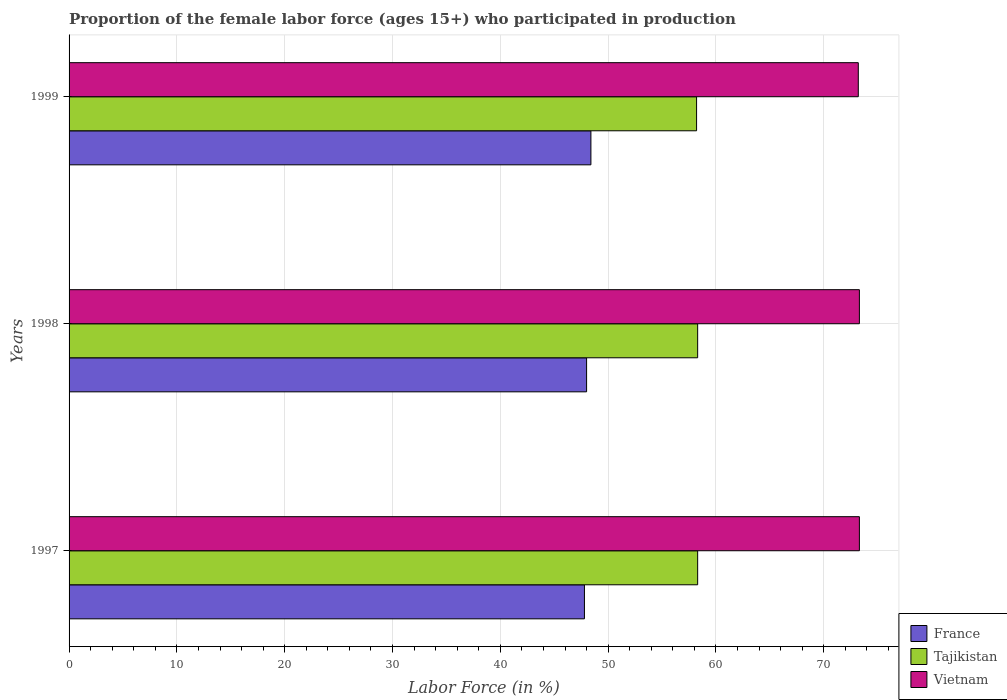How many groups of bars are there?
Give a very brief answer. 3. How many bars are there on the 2nd tick from the top?
Your response must be concise. 3. How many bars are there on the 3rd tick from the bottom?
Give a very brief answer. 3. What is the proportion of the female labor force who participated in production in Vietnam in 1998?
Your answer should be compact. 73.3. Across all years, what is the maximum proportion of the female labor force who participated in production in Vietnam?
Your answer should be very brief. 73.3. Across all years, what is the minimum proportion of the female labor force who participated in production in France?
Keep it short and to the point. 47.8. In which year was the proportion of the female labor force who participated in production in Vietnam minimum?
Ensure brevity in your answer.  1999. What is the total proportion of the female labor force who participated in production in Tajikistan in the graph?
Offer a terse response. 174.8. What is the difference between the proportion of the female labor force who participated in production in Vietnam in 1998 and that in 1999?
Provide a short and direct response. 0.1. What is the difference between the proportion of the female labor force who participated in production in France in 1997 and the proportion of the female labor force who participated in production in Vietnam in 1998?
Offer a very short reply. -25.5. What is the average proportion of the female labor force who participated in production in France per year?
Provide a succinct answer. 48.07. In the year 1998, what is the difference between the proportion of the female labor force who participated in production in Vietnam and proportion of the female labor force who participated in production in Tajikistan?
Provide a short and direct response. 15. In how many years, is the proportion of the female labor force who participated in production in France greater than 16 %?
Your answer should be compact. 3. What is the ratio of the proportion of the female labor force who participated in production in Vietnam in 1998 to that in 1999?
Provide a short and direct response. 1. Is the difference between the proportion of the female labor force who participated in production in Vietnam in 1997 and 1999 greater than the difference between the proportion of the female labor force who participated in production in Tajikistan in 1997 and 1999?
Give a very brief answer. Yes. What is the difference between the highest and the second highest proportion of the female labor force who participated in production in France?
Your answer should be very brief. 0.4. What is the difference between the highest and the lowest proportion of the female labor force who participated in production in France?
Keep it short and to the point. 0.6. What does the 1st bar from the top in 1997 represents?
Keep it short and to the point. Vietnam. What does the 2nd bar from the bottom in 1997 represents?
Offer a very short reply. Tajikistan. Is it the case that in every year, the sum of the proportion of the female labor force who participated in production in Vietnam and proportion of the female labor force who participated in production in France is greater than the proportion of the female labor force who participated in production in Tajikistan?
Make the answer very short. Yes. How many bars are there?
Keep it short and to the point. 9. Are all the bars in the graph horizontal?
Offer a terse response. Yes. What is the difference between two consecutive major ticks on the X-axis?
Make the answer very short. 10. Where does the legend appear in the graph?
Your answer should be very brief. Bottom right. How many legend labels are there?
Your response must be concise. 3. What is the title of the graph?
Provide a short and direct response. Proportion of the female labor force (ages 15+) who participated in production. Does "Eritrea" appear as one of the legend labels in the graph?
Your answer should be compact. No. What is the label or title of the X-axis?
Keep it short and to the point. Labor Force (in %). What is the label or title of the Y-axis?
Ensure brevity in your answer.  Years. What is the Labor Force (in %) of France in 1997?
Offer a terse response. 47.8. What is the Labor Force (in %) of Tajikistan in 1997?
Give a very brief answer. 58.3. What is the Labor Force (in %) of Vietnam in 1997?
Give a very brief answer. 73.3. What is the Labor Force (in %) in France in 1998?
Offer a very short reply. 48. What is the Labor Force (in %) of Tajikistan in 1998?
Ensure brevity in your answer.  58.3. What is the Labor Force (in %) of Vietnam in 1998?
Your response must be concise. 73.3. What is the Labor Force (in %) in France in 1999?
Make the answer very short. 48.4. What is the Labor Force (in %) in Tajikistan in 1999?
Offer a very short reply. 58.2. What is the Labor Force (in %) of Vietnam in 1999?
Give a very brief answer. 73.2. Across all years, what is the maximum Labor Force (in %) in France?
Offer a very short reply. 48.4. Across all years, what is the maximum Labor Force (in %) in Tajikistan?
Provide a short and direct response. 58.3. Across all years, what is the maximum Labor Force (in %) in Vietnam?
Give a very brief answer. 73.3. Across all years, what is the minimum Labor Force (in %) in France?
Provide a short and direct response. 47.8. Across all years, what is the minimum Labor Force (in %) of Tajikistan?
Offer a terse response. 58.2. Across all years, what is the minimum Labor Force (in %) of Vietnam?
Your answer should be compact. 73.2. What is the total Labor Force (in %) in France in the graph?
Give a very brief answer. 144.2. What is the total Labor Force (in %) in Tajikistan in the graph?
Make the answer very short. 174.8. What is the total Labor Force (in %) in Vietnam in the graph?
Provide a succinct answer. 219.8. What is the difference between the Labor Force (in %) of Vietnam in 1997 and that in 1998?
Provide a short and direct response. 0. What is the difference between the Labor Force (in %) of Vietnam in 1997 and that in 1999?
Offer a terse response. 0.1. What is the difference between the Labor Force (in %) of France in 1998 and that in 1999?
Make the answer very short. -0.4. What is the difference between the Labor Force (in %) in Vietnam in 1998 and that in 1999?
Offer a terse response. 0.1. What is the difference between the Labor Force (in %) of France in 1997 and the Labor Force (in %) of Tajikistan in 1998?
Ensure brevity in your answer.  -10.5. What is the difference between the Labor Force (in %) of France in 1997 and the Labor Force (in %) of Vietnam in 1998?
Ensure brevity in your answer.  -25.5. What is the difference between the Labor Force (in %) of France in 1997 and the Labor Force (in %) of Tajikistan in 1999?
Your response must be concise. -10.4. What is the difference between the Labor Force (in %) of France in 1997 and the Labor Force (in %) of Vietnam in 1999?
Give a very brief answer. -25.4. What is the difference between the Labor Force (in %) of Tajikistan in 1997 and the Labor Force (in %) of Vietnam in 1999?
Offer a very short reply. -14.9. What is the difference between the Labor Force (in %) in France in 1998 and the Labor Force (in %) in Tajikistan in 1999?
Make the answer very short. -10.2. What is the difference between the Labor Force (in %) of France in 1998 and the Labor Force (in %) of Vietnam in 1999?
Keep it short and to the point. -25.2. What is the difference between the Labor Force (in %) in Tajikistan in 1998 and the Labor Force (in %) in Vietnam in 1999?
Ensure brevity in your answer.  -14.9. What is the average Labor Force (in %) in France per year?
Give a very brief answer. 48.07. What is the average Labor Force (in %) in Tajikistan per year?
Offer a very short reply. 58.27. What is the average Labor Force (in %) of Vietnam per year?
Make the answer very short. 73.27. In the year 1997, what is the difference between the Labor Force (in %) of France and Labor Force (in %) of Vietnam?
Your response must be concise. -25.5. In the year 1998, what is the difference between the Labor Force (in %) of France and Labor Force (in %) of Vietnam?
Give a very brief answer. -25.3. In the year 1998, what is the difference between the Labor Force (in %) in Tajikistan and Labor Force (in %) in Vietnam?
Your answer should be compact. -15. In the year 1999, what is the difference between the Labor Force (in %) of France and Labor Force (in %) of Vietnam?
Make the answer very short. -24.8. In the year 1999, what is the difference between the Labor Force (in %) in Tajikistan and Labor Force (in %) in Vietnam?
Provide a short and direct response. -15. What is the ratio of the Labor Force (in %) of Tajikistan in 1997 to that in 1998?
Give a very brief answer. 1. What is the ratio of the Labor Force (in %) of France in 1997 to that in 1999?
Give a very brief answer. 0.99. What is the ratio of the Labor Force (in %) in Tajikistan in 1997 to that in 1999?
Make the answer very short. 1. What is the ratio of the Labor Force (in %) of Vietnam in 1997 to that in 1999?
Offer a terse response. 1. What is the difference between the highest and the second highest Labor Force (in %) of France?
Make the answer very short. 0.4. What is the difference between the highest and the second highest Labor Force (in %) of Tajikistan?
Provide a succinct answer. 0. What is the difference between the highest and the second highest Labor Force (in %) of Vietnam?
Give a very brief answer. 0. What is the difference between the highest and the lowest Labor Force (in %) in France?
Ensure brevity in your answer.  0.6. 